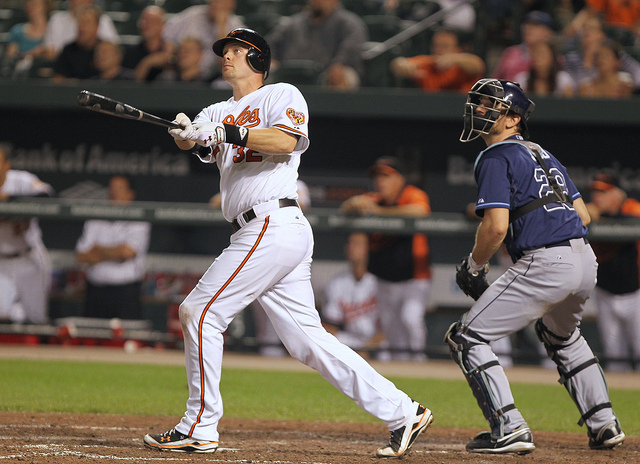Please transcribe the text in this image. 32 America 